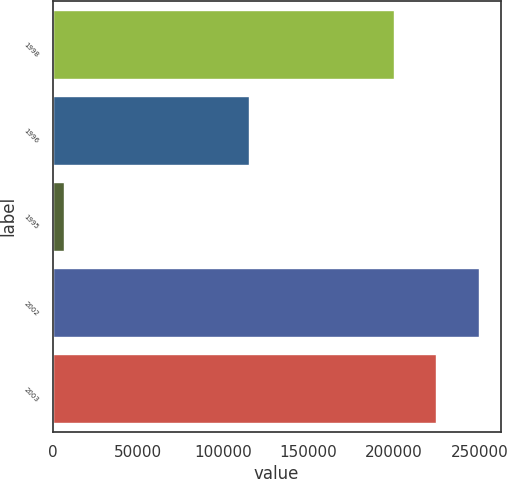<chart> <loc_0><loc_0><loc_500><loc_500><bar_chart><fcel>1998<fcel>1996<fcel>1995<fcel>2002<fcel>2003<nl><fcel>200000<fcel>115000<fcel>6421<fcel>250000<fcel>224358<nl></chart> 